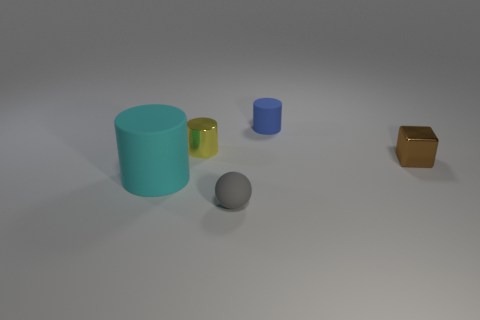Is the shape of the small shiny thing left of the brown object the same as the small rubber object that is behind the small brown metal cube?
Offer a very short reply. Yes. What number of things are small shiny things that are in front of the yellow object or big cyan shiny cubes?
Your answer should be very brief. 1. There is a tiny cylinder that is behind the small shiny object that is behind the tiny block; is there a shiny cube in front of it?
Provide a succinct answer. Yes. Is the number of small blue matte objects behind the tiny yellow metallic cylinder less than the number of tiny objects behind the small brown thing?
Provide a succinct answer. Yes. There is a sphere that is the same material as the cyan object; what color is it?
Offer a very short reply. Gray. What color is the object behind the tiny cylinder left of the rubber ball?
Keep it short and to the point. Blue. What is the shape of the yellow shiny object that is the same size as the gray sphere?
Keep it short and to the point. Cylinder. How many things are behind the thing on the right side of the blue rubber object?
Provide a short and direct response. 2. Is the small metal cube the same color as the large object?
Keep it short and to the point. No. How many other objects are the same material as the cyan object?
Your answer should be very brief. 2. 